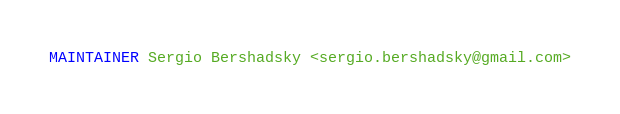<code> <loc_0><loc_0><loc_500><loc_500><_Dockerfile_>MAINTAINER Sergio Bershadsky <sergio.bershadsky@gmail.com>
</code> 